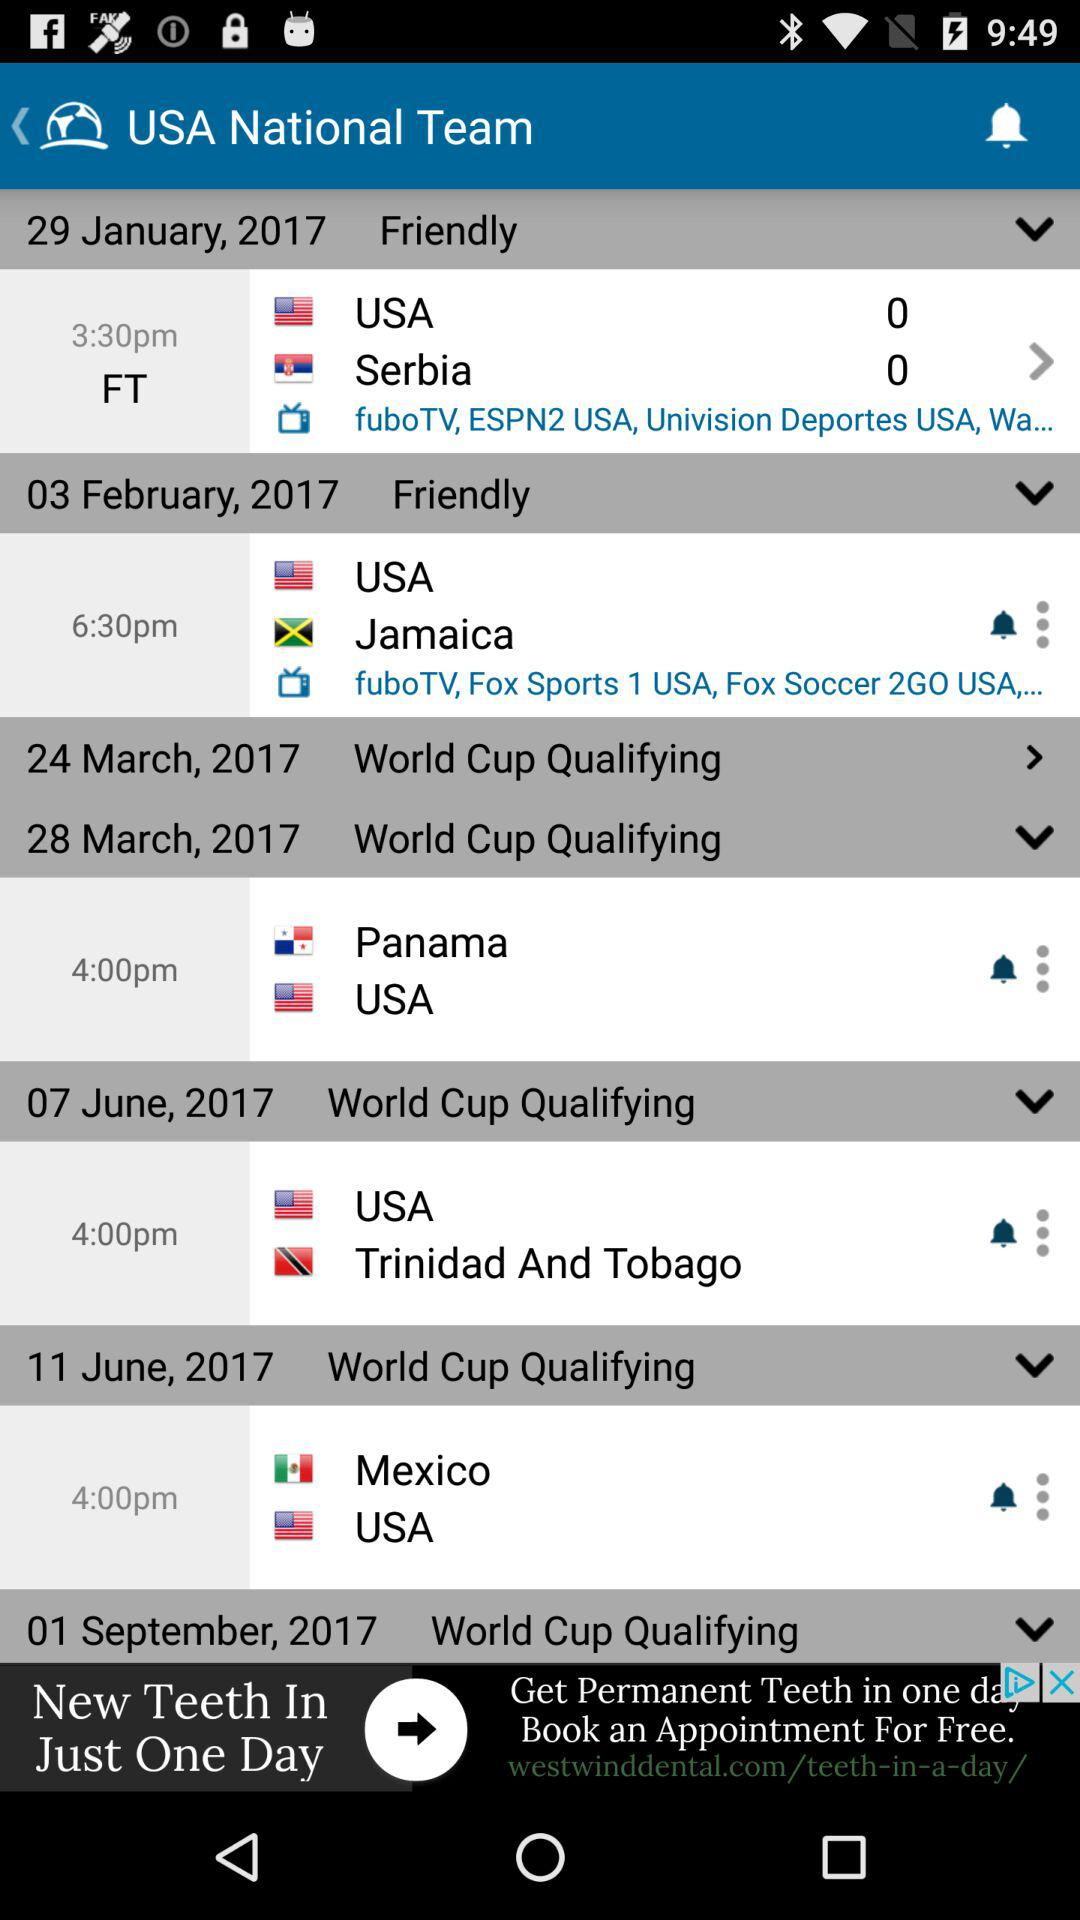Which teams are competing on January 29th, 2017? The teams are "USA" and "Serbia". 